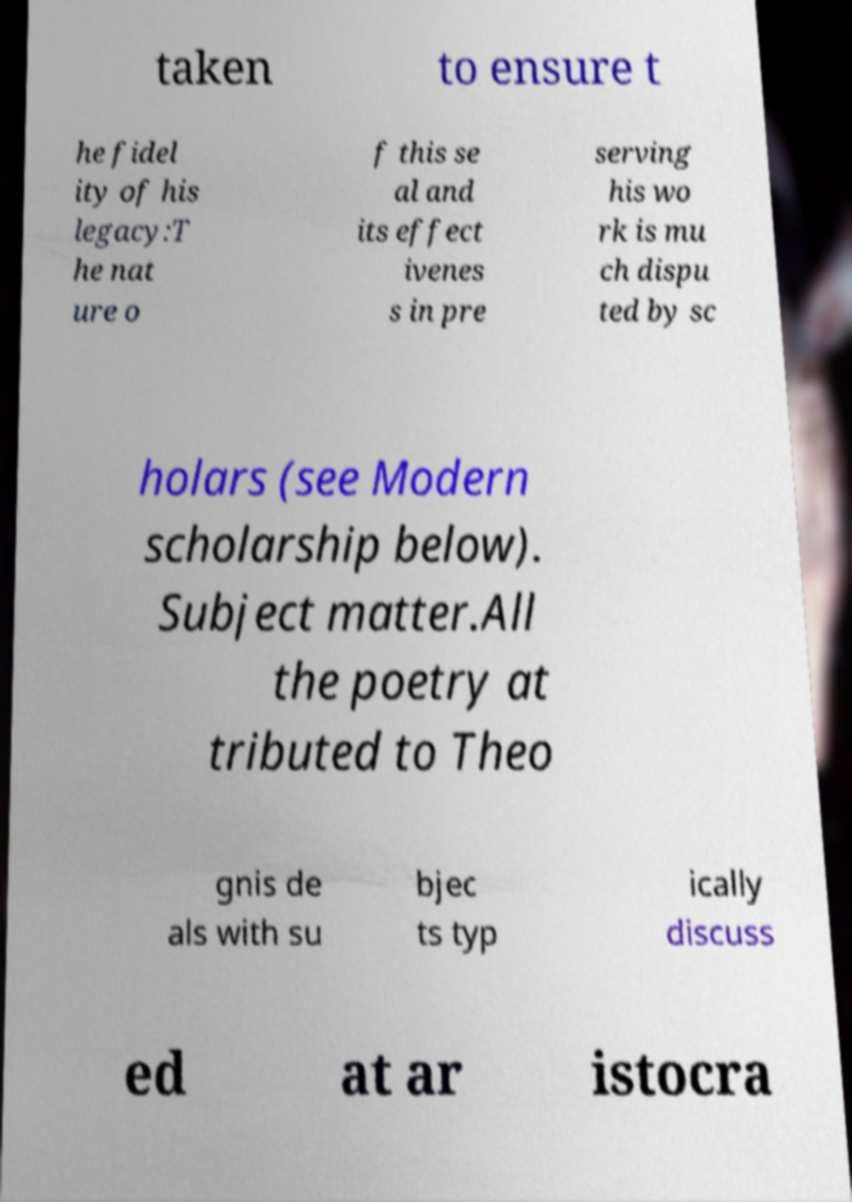Can you read and provide the text displayed in the image?This photo seems to have some interesting text. Can you extract and type it out for me? taken to ensure t he fidel ity of his legacy:T he nat ure o f this se al and its effect ivenes s in pre serving his wo rk is mu ch dispu ted by sc holars (see Modern scholarship below). Subject matter.All the poetry at tributed to Theo gnis de als with su bjec ts typ ically discuss ed at ar istocra 